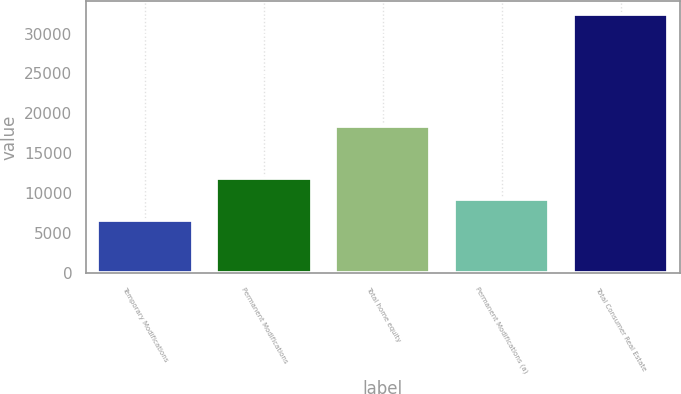Convert chart. <chart><loc_0><loc_0><loc_500><loc_500><bar_chart><fcel>Temporary Modifications<fcel>Permanent Modifications<fcel>Total home equity<fcel>Permanent Modifications (a)<fcel>Total Consumer Real Estate<nl><fcel>6683<fcel>11837.8<fcel>18400<fcel>9260.4<fcel>32457<nl></chart> 